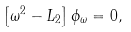Convert formula to latex. <formula><loc_0><loc_0><loc_500><loc_500>\left [ \omega ^ { 2 } - L _ { 2 } \right ] \phi _ { \omega } = 0 ,</formula> 